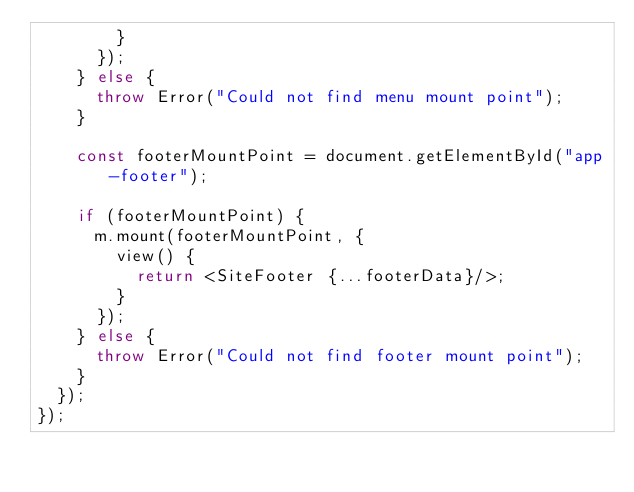<code> <loc_0><loc_0><loc_500><loc_500><_TypeScript_>        }
      });
    } else {
      throw Error("Could not find menu mount point");
    }

    const footerMountPoint = document.getElementById("app-footer");

    if (footerMountPoint) {
      m.mount(footerMountPoint, {
        view() {
          return <SiteFooter {...footerData}/>;
        }
      });
    } else {
      throw Error("Could not find footer mount point");
    }
  });
});
</code> 